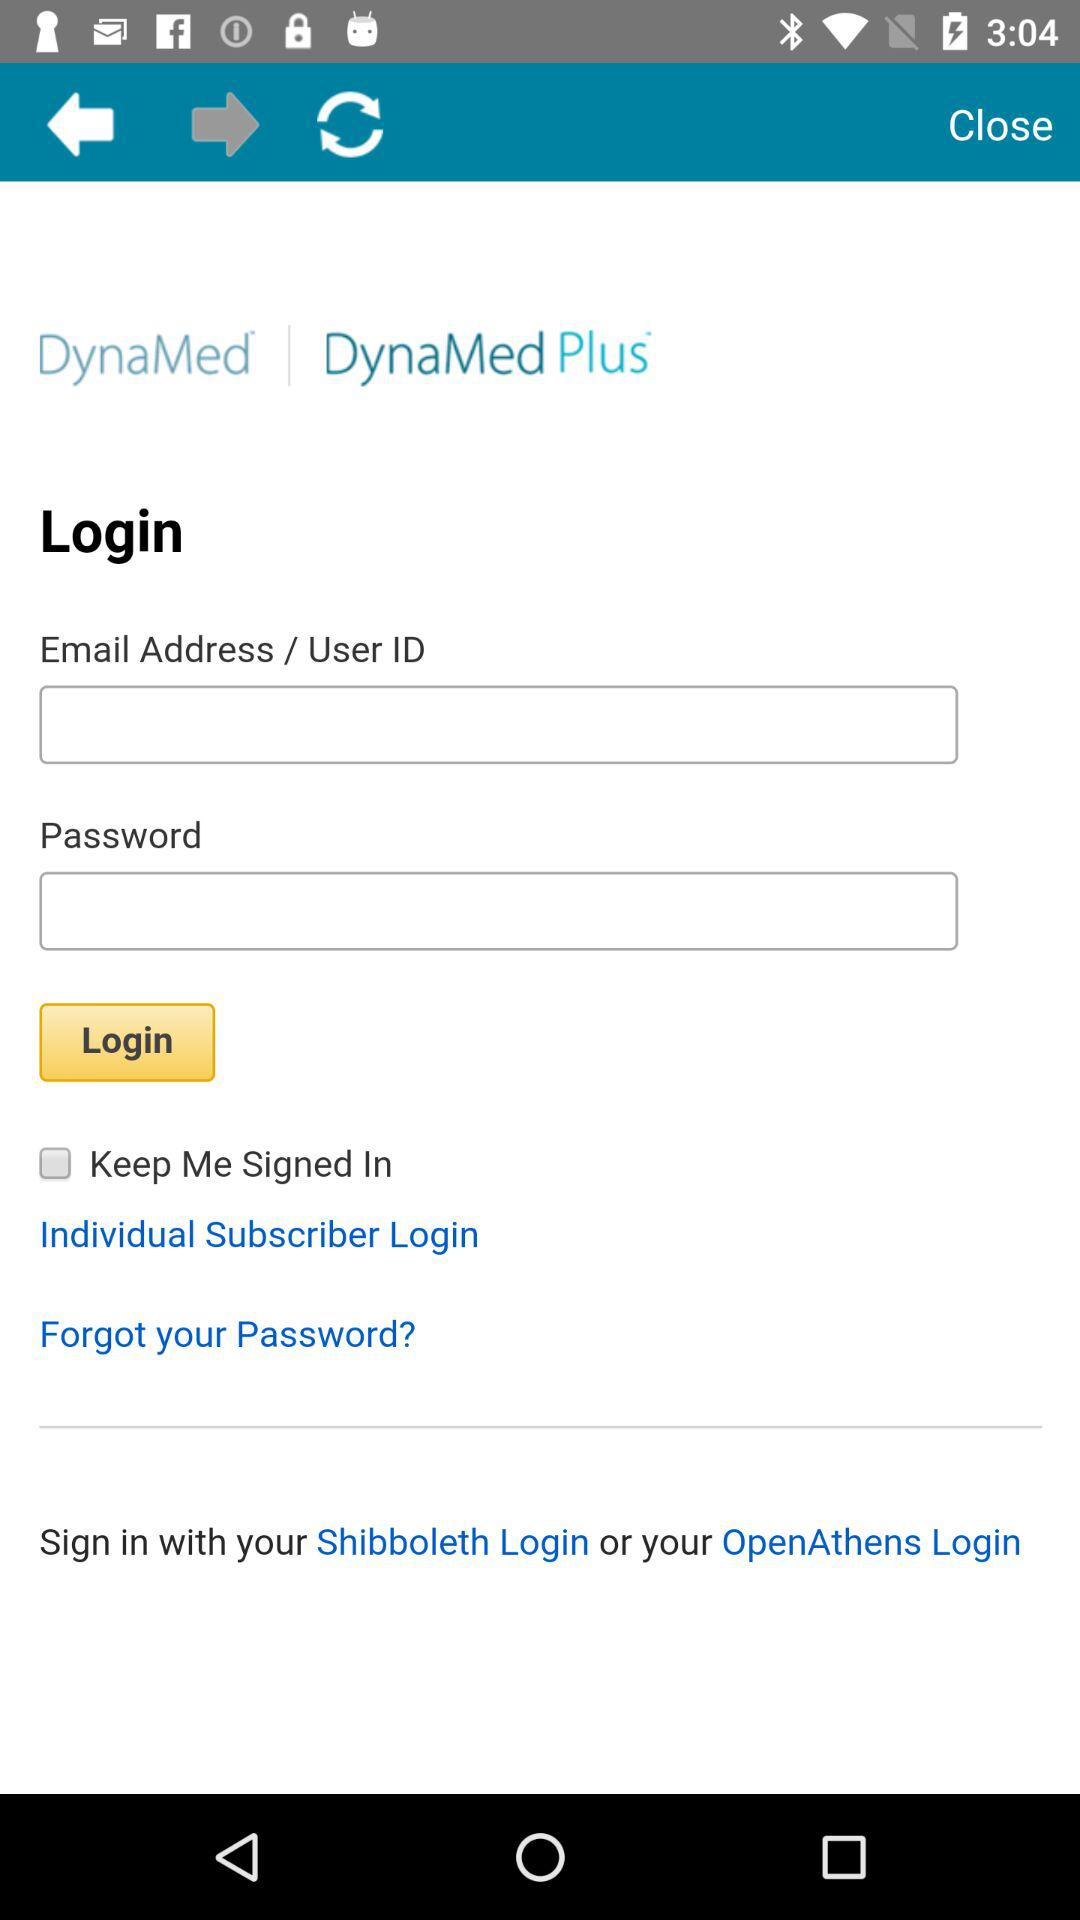What is the application name? The application name is "DynaMed". 